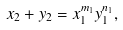<formula> <loc_0><loc_0><loc_500><loc_500>x _ { 2 } + y _ { 2 } = x _ { 1 } ^ { m _ { 1 } } y _ { 1 } ^ { n _ { 1 } } ,</formula> 